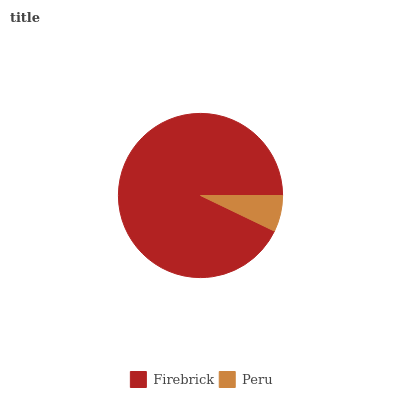Is Peru the minimum?
Answer yes or no. Yes. Is Firebrick the maximum?
Answer yes or no. Yes. Is Peru the maximum?
Answer yes or no. No. Is Firebrick greater than Peru?
Answer yes or no. Yes. Is Peru less than Firebrick?
Answer yes or no. Yes. Is Peru greater than Firebrick?
Answer yes or no. No. Is Firebrick less than Peru?
Answer yes or no. No. Is Firebrick the high median?
Answer yes or no. Yes. Is Peru the low median?
Answer yes or no. Yes. Is Peru the high median?
Answer yes or no. No. Is Firebrick the low median?
Answer yes or no. No. 